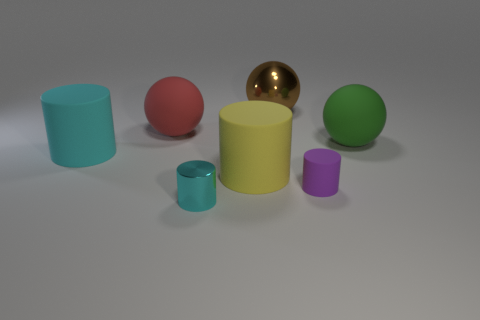How many other things are there of the same size as the green rubber object?
Keep it short and to the point. 4. There is a big ball to the left of the tiny cyan metallic object; what material is it?
Your answer should be very brief. Rubber. Does the big brown metallic object have the same shape as the purple rubber thing?
Give a very brief answer. No. How many other objects are the same shape as the tiny purple rubber object?
Your response must be concise. 3. The metal object that is in front of the large cyan cylinder is what color?
Offer a terse response. Cyan. Do the cyan matte cylinder and the green ball have the same size?
Provide a short and direct response. Yes. What is the cyan thing on the right side of the big rubber cylinder on the left side of the red sphere made of?
Ensure brevity in your answer.  Metal. How many tiny matte cylinders are the same color as the tiny matte thing?
Your answer should be very brief. 0. Are there any other things that are made of the same material as the large brown sphere?
Make the answer very short. Yes. Are there fewer large matte spheres that are behind the large green thing than purple cylinders?
Offer a very short reply. No. 